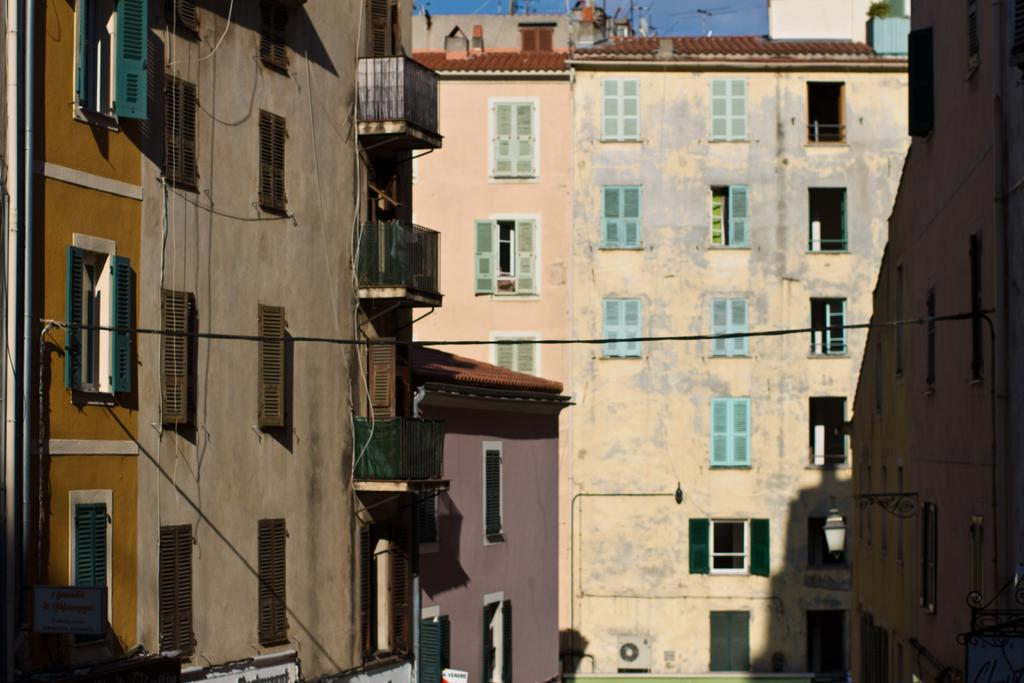What is the main subject of the image? The main subject of the image is a building in the center. What specific features can be observed on the building? The building has windows. Are there any other buildings visible in the image? Yes, there are buildings on both sides of the image. What type of hammer can be seen being used to facilitate the birth of a new development in the image? There is no hammer, birth, or development present in the image; it only features a building with windows and other buildings on both sides. 